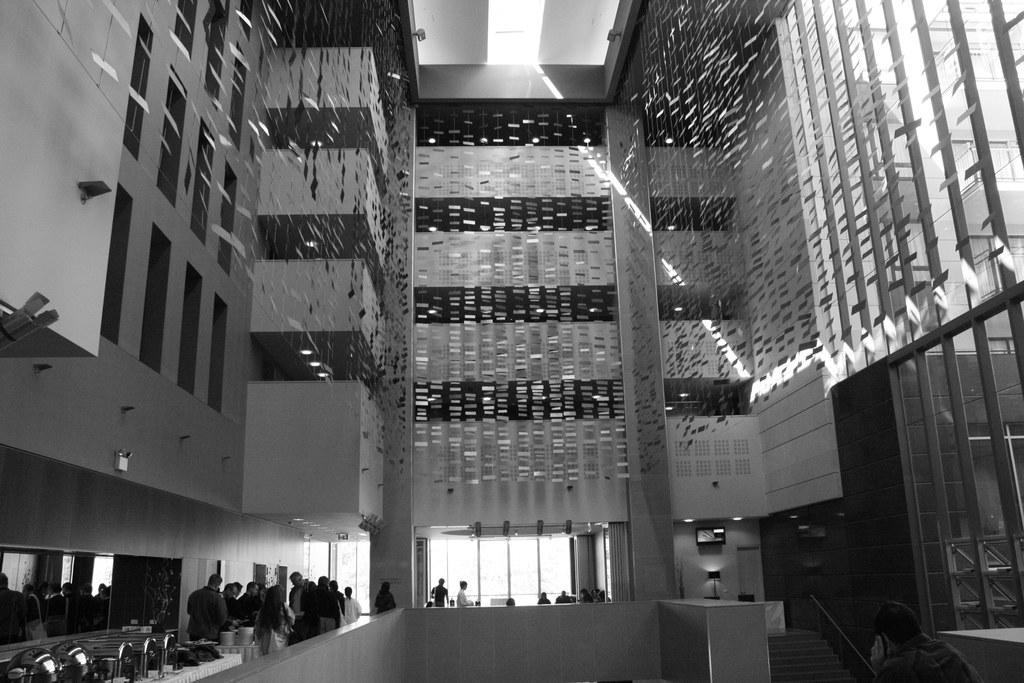What can be seen at the bottom of the image? There are persons standing in the bottom of the image. What type of structure is visible in the background of the image? There is a building in the background of the image. How many toes does the dog have in the image? There is no dog present in the image, so it is not possible to determine the number of toes it might have. 